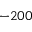<formula> <loc_0><loc_0><loc_500><loc_500>- 2 0 0</formula> 